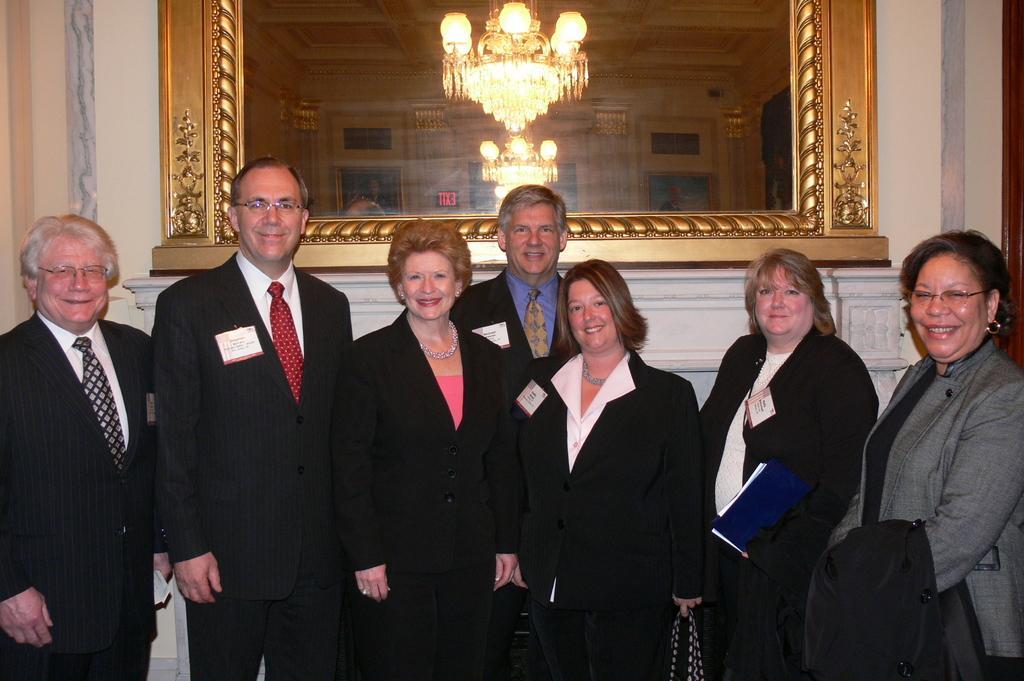Describe this image in one or two sentences. In this picture there are four women who are wearing suit. On the left there are three men who are wearing suit. Everyone is smiling. They are standing near to the wall. On the wall we can see the mirror. In the mirror we can see the reflection of the chandeliers, doors and windows. 